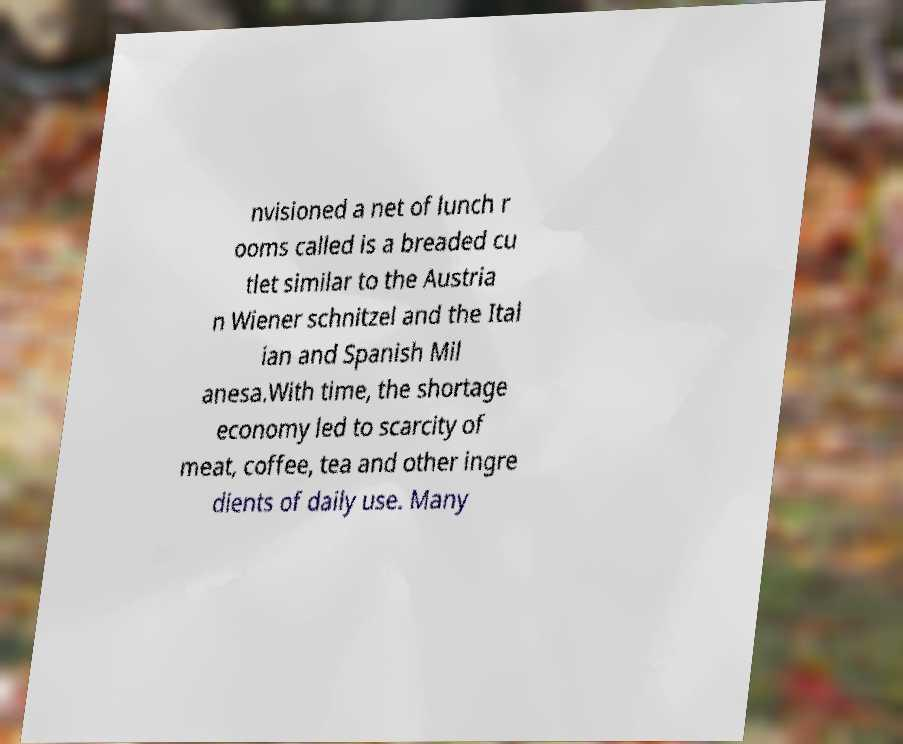I need the written content from this picture converted into text. Can you do that? nvisioned a net of lunch r ooms called is a breaded cu tlet similar to the Austria n Wiener schnitzel and the Ital ian and Spanish Mil anesa.With time, the shortage economy led to scarcity of meat, coffee, tea and other ingre dients of daily use. Many 